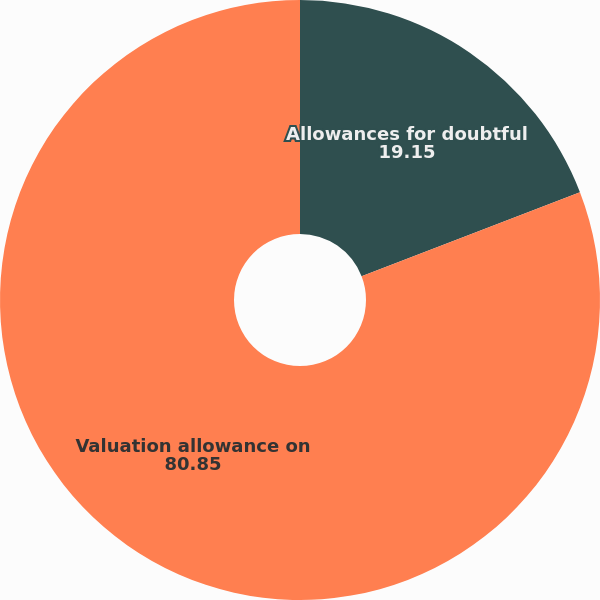Convert chart. <chart><loc_0><loc_0><loc_500><loc_500><pie_chart><fcel>Allowances for doubtful<fcel>Valuation allowance on<nl><fcel>19.15%<fcel>80.85%<nl></chart> 